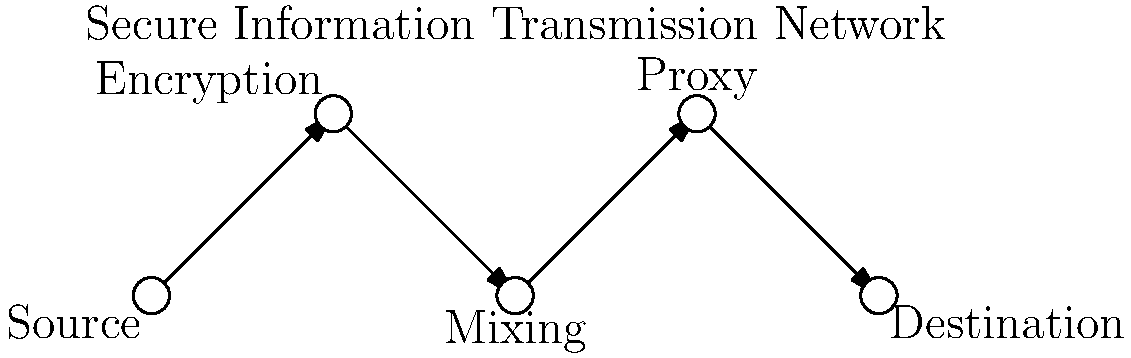Analyze the network diagram representing a secure information transmission method. Which component in this system provides the most crucial layer of anonymity for a whistleblower transmitting sensitive political campaign information, and why? To answer this question, let's examine each component of the secure information transmission network:

1. Source: This is the origin of the leaked information, likely the whistleblower's device.

2. Encryption: This step encrypts the data, making it unreadable to unauthorized parties. While crucial for security, it doesn't provide anonymity.

3. Mixing: This component mixes the encrypted data with other traffic, making it harder to trace the origin. It adds a layer of anonymity but can potentially be compromised if the mixing service is not trustworthy.

4. Proxy: This is a intermediary server that relays the information, hiding the original source's IP address. It provides a significant layer of anonymity by masking the whistleblower's identity and location.

5. Destination: This is where the leaked information is ultimately received, possibly a journalist or watchdog organization.

For a whistleblower leaking sensitive political campaign information, anonymity is paramount. While encryption secures the content and mixing obscures the data flow, the proxy provides the most crucial layer of anonymity. Here's why:

1. It hides the whistleblower's IP address, making it extremely difficult to trace the leak back to its source.
2. It adds a layer of separation between the source and the destination, further protecting the whistleblower's identity.
3. If configured correctly (e.g., using a chain of proxies or a reputable VPN service), it can provide near-complete anonymity.
4. Unlike mixing services, which may be vulnerable if compromised, a well-chosen proxy (or chain of proxies) can maintain anonymity even if one link in the chain is exposed.

Therefore, while all components contribute to security and anonymity, the proxy is the most crucial for protecting the whistleblower's identity in this scenario.
Answer: Proxy, as it masks the whistleblower's IP address and location, providing crucial anonymity. 